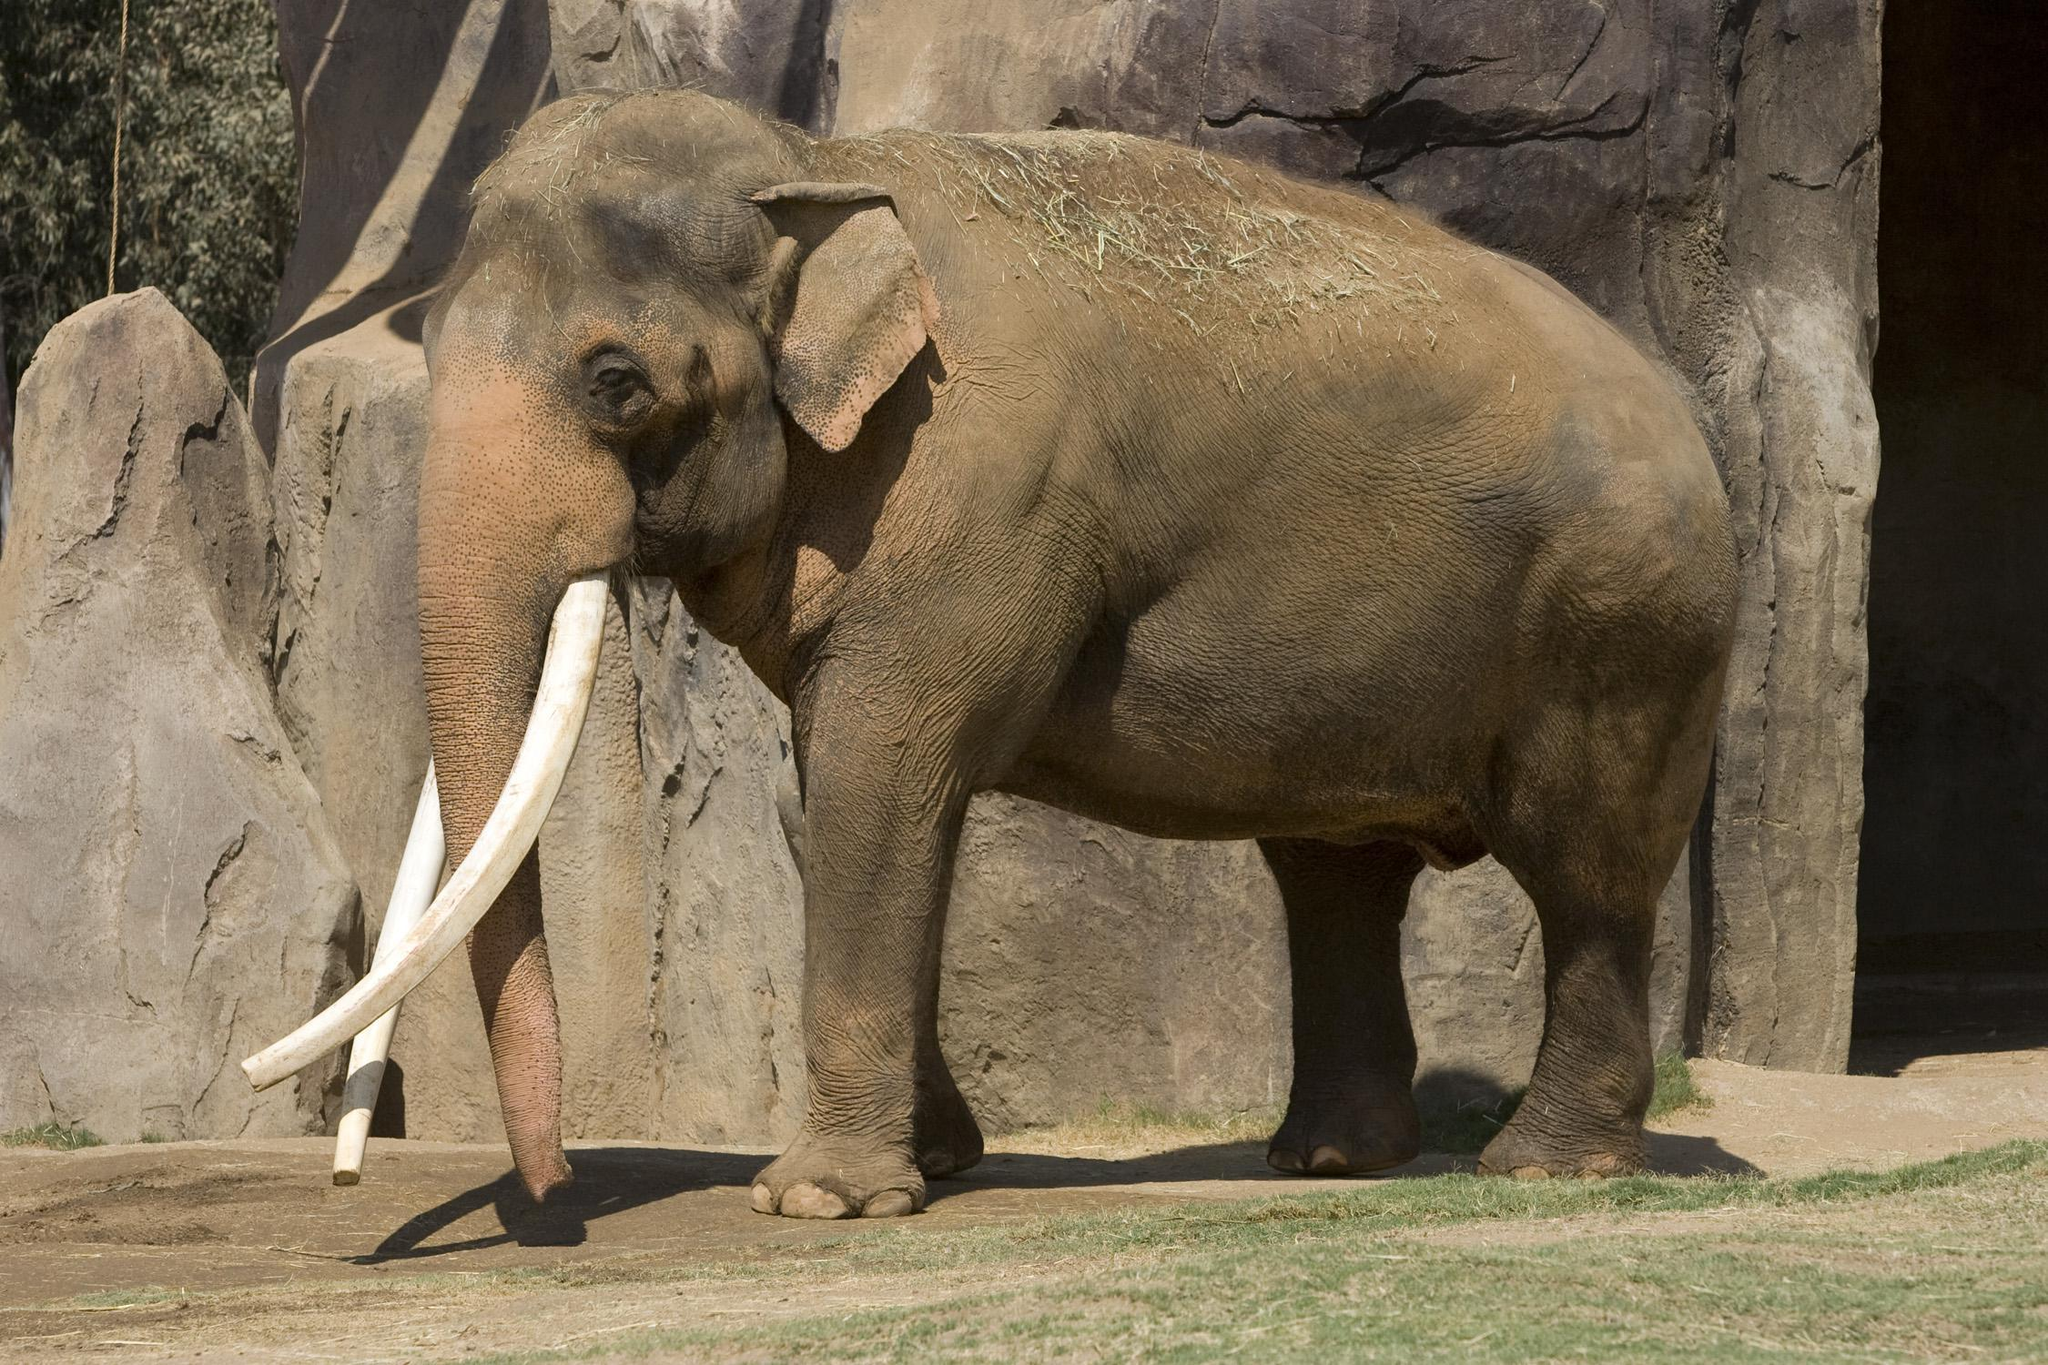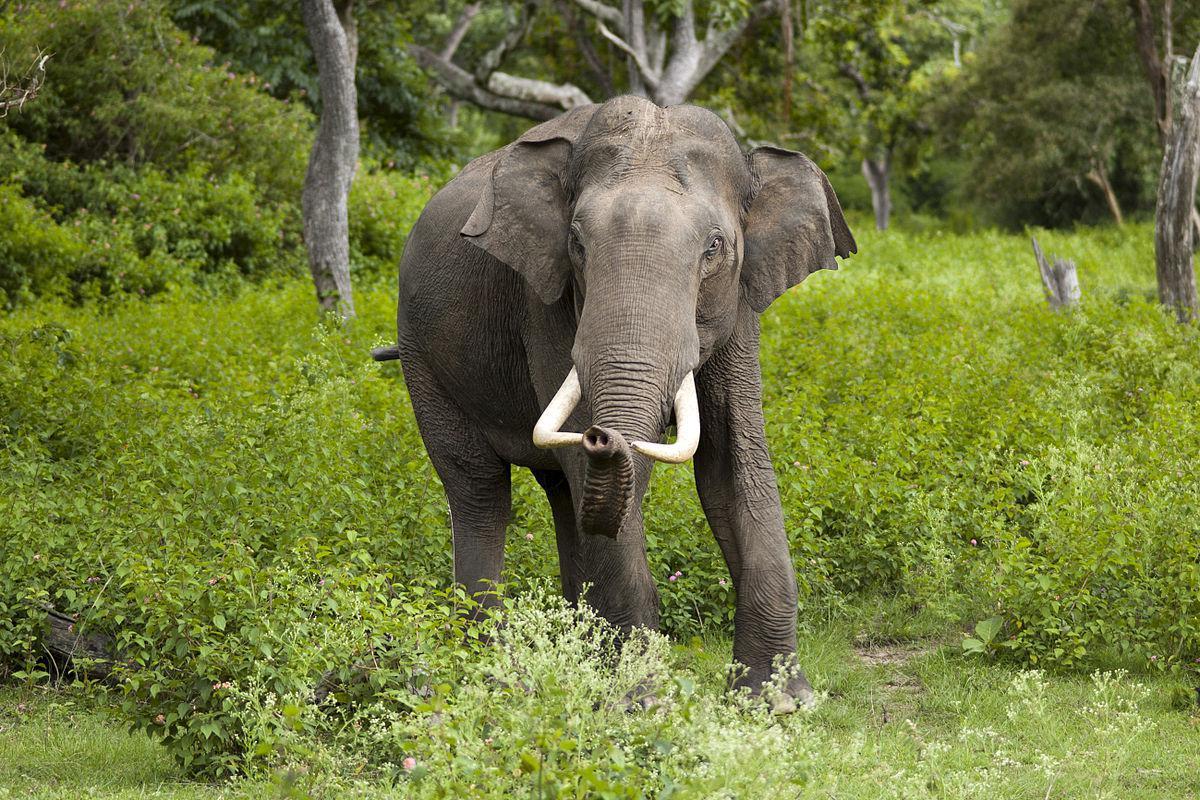The first image is the image on the left, the second image is the image on the right. For the images displayed, is the sentence "An image shows two elephants face-to-face with their faces touching." factually correct? Answer yes or no. No. The first image is the image on the left, the second image is the image on the right. Analyze the images presented: Is the assertion "Two elephants are butting heads in one of the images." valid? Answer yes or no. No. 